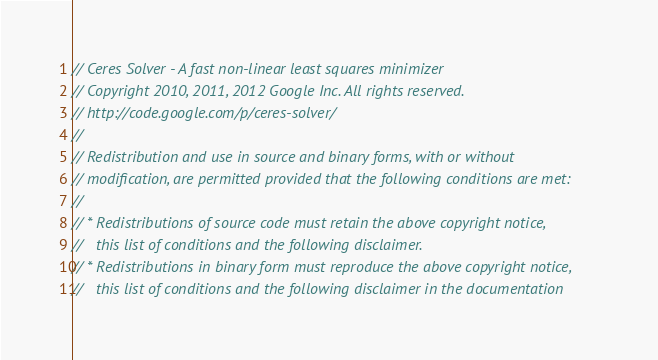Convert code to text. <code><loc_0><loc_0><loc_500><loc_500><_C++_>// Ceres Solver - A fast non-linear least squares minimizer
// Copyright 2010, 2011, 2012 Google Inc. All rights reserved.
// http://code.google.com/p/ceres-solver/
//
// Redistribution and use in source and binary forms, with or without
// modification, are permitted provided that the following conditions are met:
//
// * Redistributions of source code must retain the above copyright notice,
//   this list of conditions and the following disclaimer.
// * Redistributions in binary form must reproduce the above copyright notice,
//   this list of conditions and the following disclaimer in the documentation</code> 